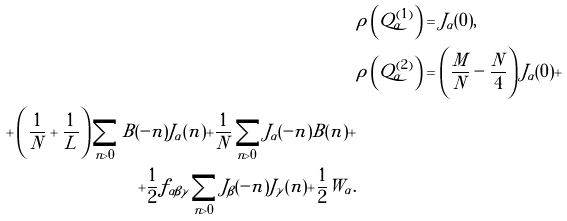<formula> <loc_0><loc_0><loc_500><loc_500>& { \rho } \left ( Q _ { \alpha } ^ { ( 1 ) } \right ) = J _ { \alpha } ( 0 ) , \\ & { \rho } \left ( Q _ { \alpha } ^ { ( 2 ) } \right ) = \left ( \frac { M } { N } - \frac { N } { 4 } \right ) J _ { \alpha } ( 0 ) + \\ + \left ( \frac { 1 } { N } + \frac { 1 } { L } \right ) \sum _ { n > 0 } B ( - n ) J _ { \alpha } ( n ) + \frac { 1 } { N } \sum _ { n > 0 } J _ { \alpha } ( - n ) B ( n ) + \\ + \frac { 1 } { 2 } f _ { \alpha \beta \gamma } \sum _ { n > 0 } J _ { \beta } ( - n ) J _ { \gamma } ( n ) + \frac { 1 } { 2 } W _ { \alpha } .</formula> 